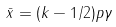Convert formula to latex. <formula><loc_0><loc_0><loc_500><loc_500>\bar { x } = ( k - 1 / 2 ) p \gamma</formula> 